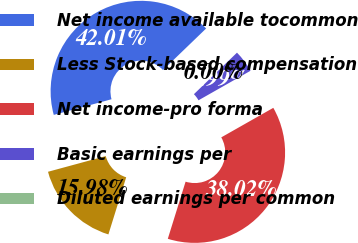Convert chart. <chart><loc_0><loc_0><loc_500><loc_500><pie_chart><fcel>Net income available tocommon<fcel>Less Stock-based compensation<fcel>Net income-pro forma<fcel>Basic earnings per<fcel>Diluted earnings per common<nl><fcel>42.01%<fcel>15.98%<fcel>38.02%<fcel>3.99%<fcel>0.0%<nl></chart> 